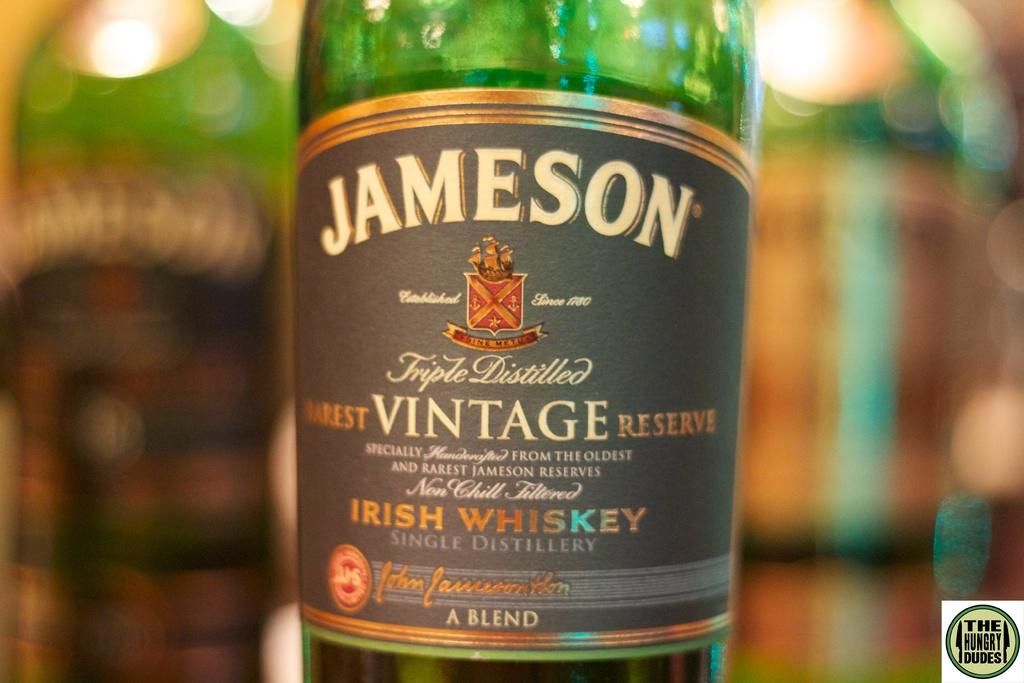<image>
Share a concise interpretation of the image provided. A bottle of vintage Jameson Irish Whiskey is made of green glass. 